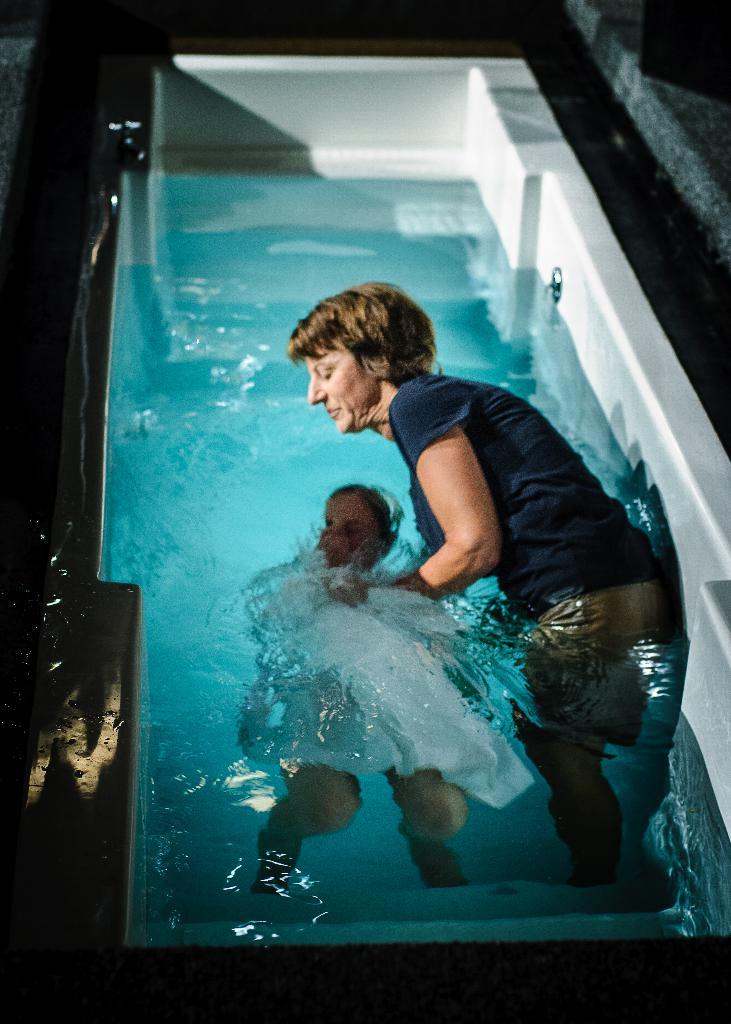Who is present in the image? There is a woman and a child in the image. What are the woman and the child doing in the image? Both the woman and the child are in a swimming pool. What type of railway can be seen near the swimming pool in the image? There is no railway present in the image; it features a woman and a child in a swimming pool. How many carts are visible near the woman and the child in the image? There are no carts visible in the image; it features a woman and a child in a swimming pool. 